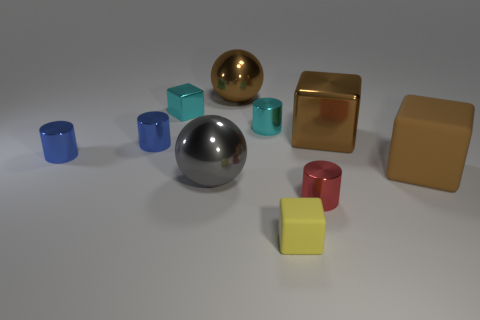There is a shiny thing that is behind the tiny cyan metal cube; is its size the same as the matte object that is in front of the red metallic cylinder?
Offer a very short reply. No. What number of things are cyan metallic objects to the right of the big brown metallic ball or tiny cylinders to the left of the big brown sphere?
Keep it short and to the point. 3. Is the material of the big brown sphere the same as the small cube on the right side of the gray shiny thing?
Offer a terse response. No. What is the shape of the big shiny thing that is left of the small yellow matte thing and in front of the small metal cube?
Provide a succinct answer. Sphere. How many other things are the same color as the small matte cube?
Offer a terse response. 0. There is a gray object; what shape is it?
Your response must be concise. Sphere. The big metallic thing behind the big brown block that is behind the big brown matte object is what color?
Provide a short and direct response. Brown. Does the large rubber cube have the same color as the big shiny thing to the right of the small red thing?
Provide a succinct answer. Yes. There is a small object that is both to the left of the tiny red shiny cylinder and on the right side of the cyan metallic cylinder; what is its material?
Provide a short and direct response. Rubber. Is there a brown metallic cube of the same size as the gray metallic ball?
Make the answer very short. Yes. 